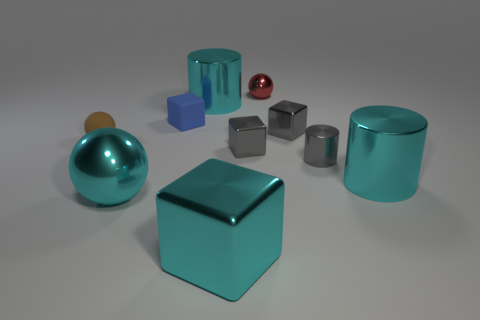There is a shiny sphere that is behind the large cyan metallic sphere; what is its size?
Your answer should be very brief. Small. How many blue cubes are the same size as the brown sphere?
Make the answer very short. 1. There is a cube that is the same material as the small brown ball; what color is it?
Your answer should be very brief. Blue. Are there fewer tiny red objects on the left side of the large cyan ball than big cyan metal cubes?
Give a very brief answer. Yes. The brown object that is the same material as the small blue object is what shape?
Your answer should be compact. Sphere. How many rubber things are blue objects or brown things?
Offer a very short reply. 2. Are there the same number of cyan shiny cylinders that are behind the tiny cylinder and blue blocks?
Make the answer very short. Yes. There is a ball that is on the left side of the big metallic sphere; does it have the same color as the large metallic sphere?
Your answer should be compact. No. What is the material of the cube that is both to the right of the blue rubber cube and behind the brown object?
Provide a succinct answer. Metal. There is a cyan metal object in front of the cyan metallic ball; is there a rubber sphere to the right of it?
Make the answer very short. No. 